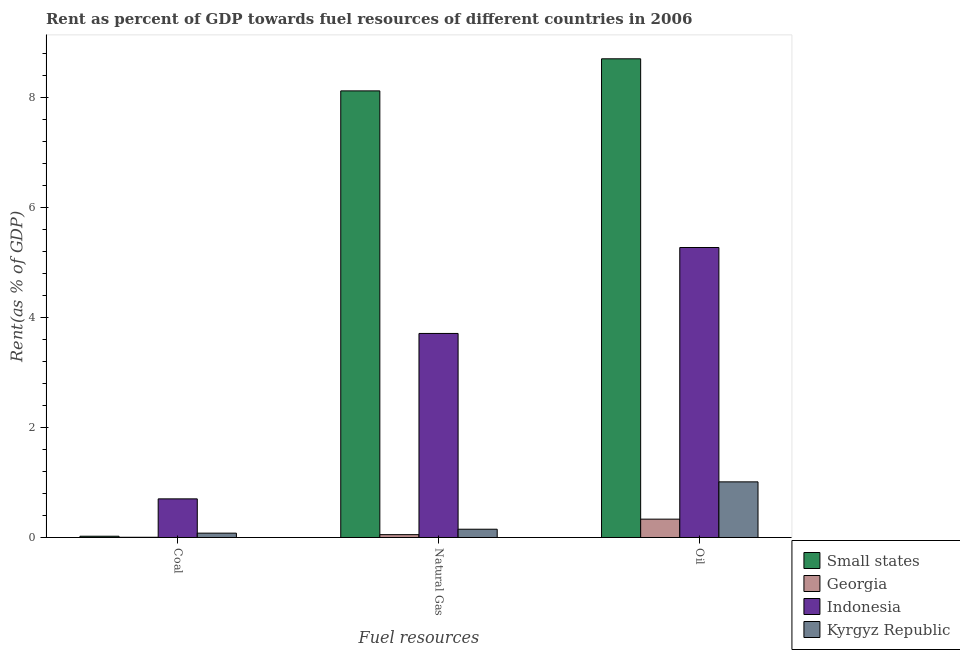How many different coloured bars are there?
Your answer should be very brief. 4. How many groups of bars are there?
Keep it short and to the point. 3. How many bars are there on the 1st tick from the left?
Provide a short and direct response. 4. What is the label of the 1st group of bars from the left?
Provide a short and direct response. Coal. What is the rent towards natural gas in Small states?
Your answer should be compact. 8.12. Across all countries, what is the maximum rent towards coal?
Provide a succinct answer. 0.7. Across all countries, what is the minimum rent towards oil?
Your response must be concise. 0.33. In which country was the rent towards coal minimum?
Your answer should be very brief. Georgia. What is the total rent towards oil in the graph?
Provide a succinct answer. 15.32. What is the difference between the rent towards oil in Indonesia and that in Georgia?
Ensure brevity in your answer.  4.94. What is the difference between the rent towards natural gas in Kyrgyz Republic and the rent towards oil in Small states?
Provide a short and direct response. -8.55. What is the average rent towards coal per country?
Your response must be concise. 0.2. What is the difference between the rent towards coal and rent towards natural gas in Georgia?
Provide a succinct answer. -0.05. What is the ratio of the rent towards coal in Kyrgyz Republic to that in Indonesia?
Give a very brief answer. 0.11. Is the difference between the rent towards natural gas in Georgia and Small states greater than the difference between the rent towards coal in Georgia and Small states?
Provide a short and direct response. No. What is the difference between the highest and the second highest rent towards natural gas?
Give a very brief answer. 4.41. What is the difference between the highest and the lowest rent towards coal?
Provide a succinct answer. 0.7. What does the 4th bar from the left in Natural Gas represents?
Offer a very short reply. Kyrgyz Republic. Is it the case that in every country, the sum of the rent towards coal and rent towards natural gas is greater than the rent towards oil?
Ensure brevity in your answer.  No. What is the difference between two consecutive major ticks on the Y-axis?
Provide a succinct answer. 2. Are the values on the major ticks of Y-axis written in scientific E-notation?
Offer a terse response. No. How many legend labels are there?
Your response must be concise. 4. What is the title of the graph?
Keep it short and to the point. Rent as percent of GDP towards fuel resources of different countries in 2006. What is the label or title of the X-axis?
Keep it short and to the point. Fuel resources. What is the label or title of the Y-axis?
Your answer should be very brief. Rent(as % of GDP). What is the Rent(as % of GDP) in Small states in Coal?
Keep it short and to the point. 0.02. What is the Rent(as % of GDP) of Georgia in Coal?
Your response must be concise. 0. What is the Rent(as % of GDP) in Indonesia in Coal?
Offer a very short reply. 0.7. What is the Rent(as % of GDP) in Kyrgyz Republic in Coal?
Offer a terse response. 0.08. What is the Rent(as % of GDP) in Small states in Natural Gas?
Your response must be concise. 8.12. What is the Rent(as % of GDP) of Georgia in Natural Gas?
Keep it short and to the point. 0.05. What is the Rent(as % of GDP) in Indonesia in Natural Gas?
Keep it short and to the point. 3.71. What is the Rent(as % of GDP) in Kyrgyz Republic in Natural Gas?
Provide a short and direct response. 0.15. What is the Rent(as % of GDP) in Small states in Oil?
Your response must be concise. 8.7. What is the Rent(as % of GDP) in Georgia in Oil?
Your response must be concise. 0.33. What is the Rent(as % of GDP) of Indonesia in Oil?
Ensure brevity in your answer.  5.27. What is the Rent(as % of GDP) in Kyrgyz Republic in Oil?
Your response must be concise. 1.01. Across all Fuel resources, what is the maximum Rent(as % of GDP) in Small states?
Your answer should be compact. 8.7. Across all Fuel resources, what is the maximum Rent(as % of GDP) of Georgia?
Provide a succinct answer. 0.33. Across all Fuel resources, what is the maximum Rent(as % of GDP) of Indonesia?
Provide a succinct answer. 5.27. Across all Fuel resources, what is the maximum Rent(as % of GDP) of Kyrgyz Republic?
Offer a terse response. 1.01. Across all Fuel resources, what is the minimum Rent(as % of GDP) in Small states?
Give a very brief answer. 0.02. Across all Fuel resources, what is the minimum Rent(as % of GDP) in Georgia?
Provide a succinct answer. 0. Across all Fuel resources, what is the minimum Rent(as % of GDP) in Indonesia?
Your response must be concise. 0.7. Across all Fuel resources, what is the minimum Rent(as % of GDP) in Kyrgyz Republic?
Make the answer very short. 0.08. What is the total Rent(as % of GDP) in Small states in the graph?
Your response must be concise. 16.85. What is the total Rent(as % of GDP) in Georgia in the graph?
Ensure brevity in your answer.  0.39. What is the total Rent(as % of GDP) of Indonesia in the graph?
Provide a succinct answer. 9.69. What is the total Rent(as % of GDP) in Kyrgyz Republic in the graph?
Offer a very short reply. 1.24. What is the difference between the Rent(as % of GDP) in Small states in Coal and that in Natural Gas?
Keep it short and to the point. -8.1. What is the difference between the Rent(as % of GDP) of Georgia in Coal and that in Natural Gas?
Offer a very short reply. -0.05. What is the difference between the Rent(as % of GDP) in Indonesia in Coal and that in Natural Gas?
Your answer should be compact. -3.01. What is the difference between the Rent(as % of GDP) in Kyrgyz Republic in Coal and that in Natural Gas?
Give a very brief answer. -0.07. What is the difference between the Rent(as % of GDP) in Small states in Coal and that in Oil?
Provide a succinct answer. -8.68. What is the difference between the Rent(as % of GDP) of Georgia in Coal and that in Oil?
Provide a succinct answer. -0.33. What is the difference between the Rent(as % of GDP) in Indonesia in Coal and that in Oil?
Make the answer very short. -4.57. What is the difference between the Rent(as % of GDP) of Kyrgyz Republic in Coal and that in Oil?
Offer a very short reply. -0.93. What is the difference between the Rent(as % of GDP) of Small states in Natural Gas and that in Oil?
Keep it short and to the point. -0.58. What is the difference between the Rent(as % of GDP) of Georgia in Natural Gas and that in Oil?
Your answer should be very brief. -0.28. What is the difference between the Rent(as % of GDP) of Indonesia in Natural Gas and that in Oil?
Provide a succinct answer. -1.56. What is the difference between the Rent(as % of GDP) in Kyrgyz Republic in Natural Gas and that in Oil?
Provide a succinct answer. -0.86. What is the difference between the Rent(as % of GDP) of Small states in Coal and the Rent(as % of GDP) of Georgia in Natural Gas?
Ensure brevity in your answer.  -0.03. What is the difference between the Rent(as % of GDP) in Small states in Coal and the Rent(as % of GDP) in Indonesia in Natural Gas?
Keep it short and to the point. -3.69. What is the difference between the Rent(as % of GDP) of Small states in Coal and the Rent(as % of GDP) of Kyrgyz Republic in Natural Gas?
Your answer should be very brief. -0.13. What is the difference between the Rent(as % of GDP) in Georgia in Coal and the Rent(as % of GDP) in Indonesia in Natural Gas?
Your answer should be very brief. -3.71. What is the difference between the Rent(as % of GDP) in Georgia in Coal and the Rent(as % of GDP) in Kyrgyz Republic in Natural Gas?
Offer a very short reply. -0.15. What is the difference between the Rent(as % of GDP) of Indonesia in Coal and the Rent(as % of GDP) of Kyrgyz Republic in Natural Gas?
Provide a succinct answer. 0.55. What is the difference between the Rent(as % of GDP) in Small states in Coal and the Rent(as % of GDP) in Georgia in Oil?
Offer a terse response. -0.31. What is the difference between the Rent(as % of GDP) of Small states in Coal and the Rent(as % of GDP) of Indonesia in Oil?
Your answer should be compact. -5.25. What is the difference between the Rent(as % of GDP) of Small states in Coal and the Rent(as % of GDP) of Kyrgyz Republic in Oil?
Your response must be concise. -0.99. What is the difference between the Rent(as % of GDP) of Georgia in Coal and the Rent(as % of GDP) of Indonesia in Oil?
Offer a terse response. -5.27. What is the difference between the Rent(as % of GDP) in Georgia in Coal and the Rent(as % of GDP) in Kyrgyz Republic in Oil?
Offer a terse response. -1.01. What is the difference between the Rent(as % of GDP) in Indonesia in Coal and the Rent(as % of GDP) in Kyrgyz Republic in Oil?
Offer a terse response. -0.31. What is the difference between the Rent(as % of GDP) of Small states in Natural Gas and the Rent(as % of GDP) of Georgia in Oil?
Offer a terse response. 7.79. What is the difference between the Rent(as % of GDP) of Small states in Natural Gas and the Rent(as % of GDP) of Indonesia in Oil?
Give a very brief answer. 2.85. What is the difference between the Rent(as % of GDP) of Small states in Natural Gas and the Rent(as % of GDP) of Kyrgyz Republic in Oil?
Ensure brevity in your answer.  7.11. What is the difference between the Rent(as % of GDP) of Georgia in Natural Gas and the Rent(as % of GDP) of Indonesia in Oil?
Keep it short and to the point. -5.22. What is the difference between the Rent(as % of GDP) in Georgia in Natural Gas and the Rent(as % of GDP) in Kyrgyz Republic in Oil?
Provide a succinct answer. -0.96. What is the difference between the Rent(as % of GDP) in Indonesia in Natural Gas and the Rent(as % of GDP) in Kyrgyz Republic in Oil?
Offer a terse response. 2.7. What is the average Rent(as % of GDP) in Small states per Fuel resources?
Make the answer very short. 5.62. What is the average Rent(as % of GDP) in Georgia per Fuel resources?
Your answer should be very brief. 0.13. What is the average Rent(as % of GDP) of Indonesia per Fuel resources?
Give a very brief answer. 3.23. What is the average Rent(as % of GDP) in Kyrgyz Republic per Fuel resources?
Offer a terse response. 0.41. What is the difference between the Rent(as % of GDP) of Small states and Rent(as % of GDP) of Georgia in Coal?
Keep it short and to the point. 0.02. What is the difference between the Rent(as % of GDP) in Small states and Rent(as % of GDP) in Indonesia in Coal?
Your answer should be very brief. -0.68. What is the difference between the Rent(as % of GDP) in Small states and Rent(as % of GDP) in Kyrgyz Republic in Coal?
Your response must be concise. -0.06. What is the difference between the Rent(as % of GDP) in Georgia and Rent(as % of GDP) in Indonesia in Coal?
Provide a succinct answer. -0.7. What is the difference between the Rent(as % of GDP) in Georgia and Rent(as % of GDP) in Kyrgyz Republic in Coal?
Give a very brief answer. -0.07. What is the difference between the Rent(as % of GDP) of Indonesia and Rent(as % of GDP) of Kyrgyz Republic in Coal?
Make the answer very short. 0.62. What is the difference between the Rent(as % of GDP) in Small states and Rent(as % of GDP) in Georgia in Natural Gas?
Your answer should be very brief. 8.07. What is the difference between the Rent(as % of GDP) of Small states and Rent(as % of GDP) of Indonesia in Natural Gas?
Provide a short and direct response. 4.41. What is the difference between the Rent(as % of GDP) of Small states and Rent(as % of GDP) of Kyrgyz Republic in Natural Gas?
Offer a very short reply. 7.97. What is the difference between the Rent(as % of GDP) in Georgia and Rent(as % of GDP) in Indonesia in Natural Gas?
Your answer should be compact. -3.66. What is the difference between the Rent(as % of GDP) in Georgia and Rent(as % of GDP) in Kyrgyz Republic in Natural Gas?
Offer a terse response. -0.1. What is the difference between the Rent(as % of GDP) in Indonesia and Rent(as % of GDP) in Kyrgyz Republic in Natural Gas?
Keep it short and to the point. 3.56. What is the difference between the Rent(as % of GDP) of Small states and Rent(as % of GDP) of Georgia in Oil?
Make the answer very short. 8.37. What is the difference between the Rent(as % of GDP) of Small states and Rent(as % of GDP) of Indonesia in Oil?
Your response must be concise. 3.43. What is the difference between the Rent(as % of GDP) of Small states and Rent(as % of GDP) of Kyrgyz Republic in Oil?
Provide a succinct answer. 7.69. What is the difference between the Rent(as % of GDP) of Georgia and Rent(as % of GDP) of Indonesia in Oil?
Provide a succinct answer. -4.94. What is the difference between the Rent(as % of GDP) in Georgia and Rent(as % of GDP) in Kyrgyz Republic in Oil?
Ensure brevity in your answer.  -0.68. What is the difference between the Rent(as % of GDP) of Indonesia and Rent(as % of GDP) of Kyrgyz Republic in Oil?
Make the answer very short. 4.26. What is the ratio of the Rent(as % of GDP) in Small states in Coal to that in Natural Gas?
Your answer should be compact. 0. What is the ratio of the Rent(as % of GDP) of Georgia in Coal to that in Natural Gas?
Offer a terse response. 0.08. What is the ratio of the Rent(as % of GDP) in Indonesia in Coal to that in Natural Gas?
Offer a very short reply. 0.19. What is the ratio of the Rent(as % of GDP) of Kyrgyz Republic in Coal to that in Natural Gas?
Offer a very short reply. 0.52. What is the ratio of the Rent(as % of GDP) of Small states in Coal to that in Oil?
Ensure brevity in your answer.  0. What is the ratio of the Rent(as % of GDP) in Georgia in Coal to that in Oil?
Give a very brief answer. 0.01. What is the ratio of the Rent(as % of GDP) in Indonesia in Coal to that in Oil?
Offer a terse response. 0.13. What is the ratio of the Rent(as % of GDP) of Kyrgyz Republic in Coal to that in Oil?
Your answer should be very brief. 0.08. What is the ratio of the Rent(as % of GDP) of Small states in Natural Gas to that in Oil?
Offer a terse response. 0.93. What is the ratio of the Rent(as % of GDP) in Georgia in Natural Gas to that in Oil?
Your answer should be compact. 0.15. What is the ratio of the Rent(as % of GDP) of Indonesia in Natural Gas to that in Oil?
Offer a terse response. 0.7. What is the ratio of the Rent(as % of GDP) in Kyrgyz Republic in Natural Gas to that in Oil?
Your response must be concise. 0.15. What is the difference between the highest and the second highest Rent(as % of GDP) of Small states?
Your answer should be very brief. 0.58. What is the difference between the highest and the second highest Rent(as % of GDP) in Georgia?
Provide a succinct answer. 0.28. What is the difference between the highest and the second highest Rent(as % of GDP) of Indonesia?
Ensure brevity in your answer.  1.56. What is the difference between the highest and the second highest Rent(as % of GDP) of Kyrgyz Republic?
Provide a succinct answer. 0.86. What is the difference between the highest and the lowest Rent(as % of GDP) in Small states?
Offer a very short reply. 8.68. What is the difference between the highest and the lowest Rent(as % of GDP) in Georgia?
Offer a terse response. 0.33. What is the difference between the highest and the lowest Rent(as % of GDP) of Indonesia?
Your response must be concise. 4.57. What is the difference between the highest and the lowest Rent(as % of GDP) in Kyrgyz Republic?
Make the answer very short. 0.93. 